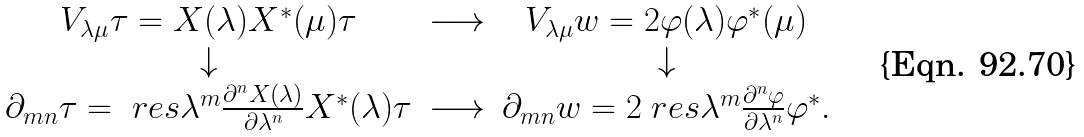Convert formula to latex. <formula><loc_0><loc_0><loc_500><loc_500>\begin{array} { c c c } V _ { \lambda \mu } \tau = X ( \lambda ) X ^ { * } ( \mu ) \tau & \longrightarrow & V _ { \lambda \mu } w = 2 \varphi ( \lambda ) \varphi ^ { * } ( \mu ) \\ \downarrow & & \downarrow \\ \partial _ { m n } \tau = \ r e s \lambda ^ { m } \frac { \partial ^ { n } X ( \lambda ) } { \partial \lambda ^ { n } } X ^ { * } ( \lambda ) \tau & \longrightarrow & \partial _ { m n } w = 2 \ r e s \lambda ^ { m } \frac { \partial ^ { n } \varphi } { \partial \lambda ^ { n } } \varphi ^ { * } . \end{array}</formula> 